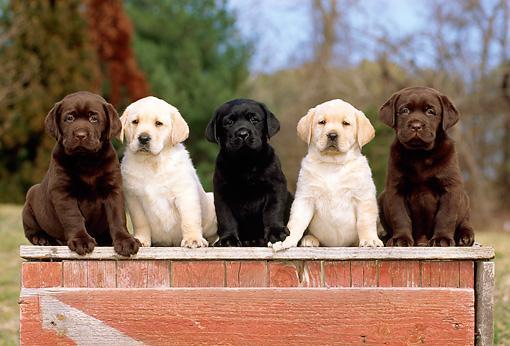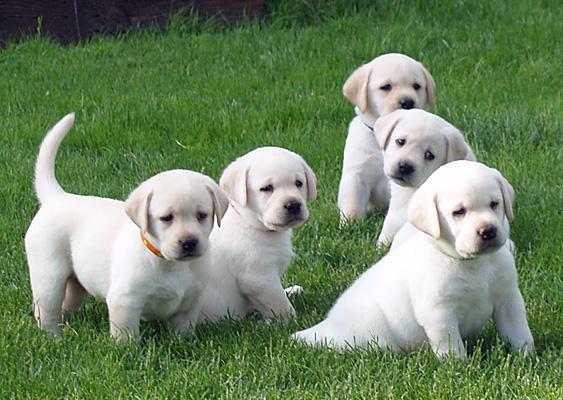The first image is the image on the left, the second image is the image on the right. Examine the images to the left and right. Is the description "There is one black dog" accurate? Answer yes or no. Yes. The first image is the image on the left, the second image is the image on the right. For the images shown, is this caption "There are exactly five dogs in the image on the left." true? Answer yes or no. Yes. 